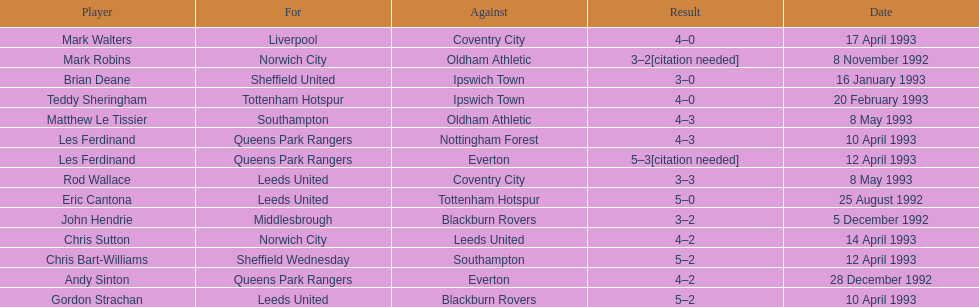How many players were for leeds united? 3. 